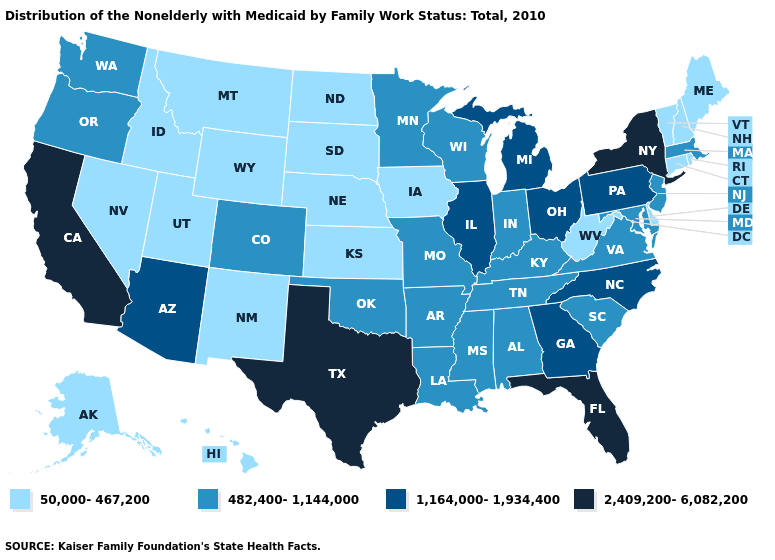Does the map have missing data?
Be succinct. No. What is the value of Iowa?
Write a very short answer. 50,000-467,200. Name the states that have a value in the range 1,164,000-1,934,400?
Answer briefly. Arizona, Georgia, Illinois, Michigan, North Carolina, Ohio, Pennsylvania. Among the states that border Utah , which have the highest value?
Short answer required. Arizona. Is the legend a continuous bar?
Concise answer only. No. Does Kansas have the highest value in the MidWest?
Be succinct. No. Name the states that have a value in the range 50,000-467,200?
Write a very short answer. Alaska, Connecticut, Delaware, Hawaii, Idaho, Iowa, Kansas, Maine, Montana, Nebraska, Nevada, New Hampshire, New Mexico, North Dakota, Rhode Island, South Dakota, Utah, Vermont, West Virginia, Wyoming. What is the lowest value in the MidWest?
Keep it brief. 50,000-467,200. Name the states that have a value in the range 1,164,000-1,934,400?
Short answer required. Arizona, Georgia, Illinois, Michigan, North Carolina, Ohio, Pennsylvania. What is the lowest value in the Northeast?
Quick response, please. 50,000-467,200. Which states have the lowest value in the Northeast?
Concise answer only. Connecticut, Maine, New Hampshire, Rhode Island, Vermont. Name the states that have a value in the range 482,400-1,144,000?
Concise answer only. Alabama, Arkansas, Colorado, Indiana, Kentucky, Louisiana, Maryland, Massachusetts, Minnesota, Mississippi, Missouri, New Jersey, Oklahoma, Oregon, South Carolina, Tennessee, Virginia, Washington, Wisconsin. Name the states that have a value in the range 50,000-467,200?
Short answer required. Alaska, Connecticut, Delaware, Hawaii, Idaho, Iowa, Kansas, Maine, Montana, Nebraska, Nevada, New Hampshire, New Mexico, North Dakota, Rhode Island, South Dakota, Utah, Vermont, West Virginia, Wyoming. Name the states that have a value in the range 482,400-1,144,000?
Be succinct. Alabama, Arkansas, Colorado, Indiana, Kentucky, Louisiana, Maryland, Massachusetts, Minnesota, Mississippi, Missouri, New Jersey, Oklahoma, Oregon, South Carolina, Tennessee, Virginia, Washington, Wisconsin. Does Minnesota have the same value as Ohio?
Give a very brief answer. No. 